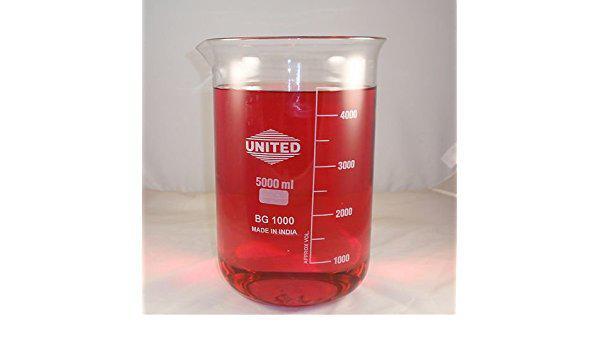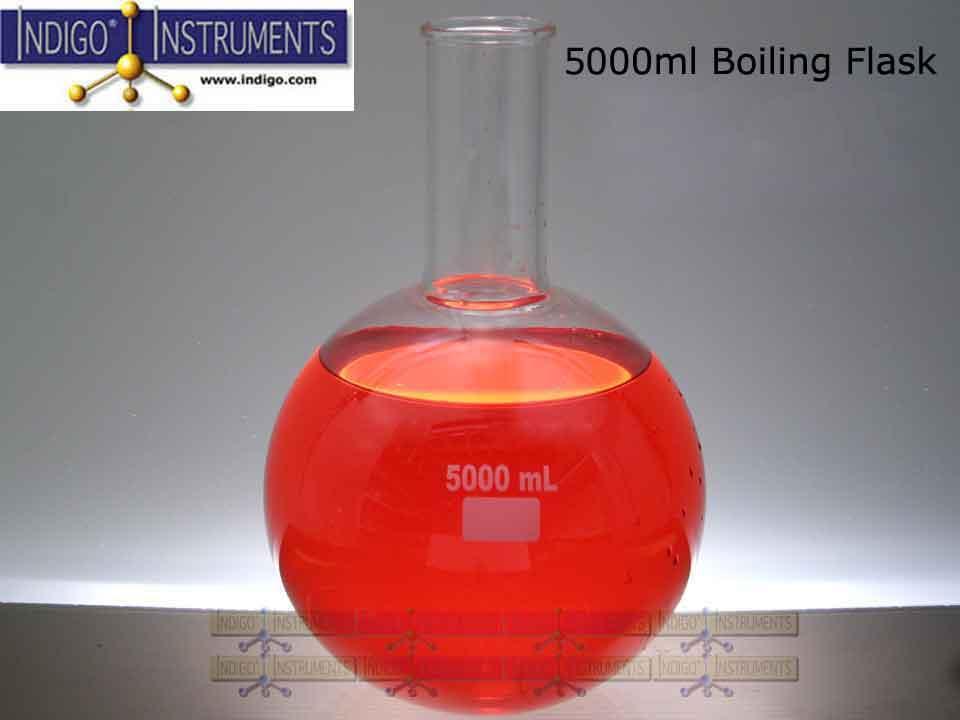The first image is the image on the left, the second image is the image on the right. For the images shown, is this caption "One of the images contains a flask rather than a beaker." true? Answer yes or no. Yes. The first image is the image on the left, the second image is the image on the right. Evaluate the accuracy of this statement regarding the images: "One of the images shows an empty flask and the other image shows a flask containing liquid.". Is it true? Answer yes or no. No. 